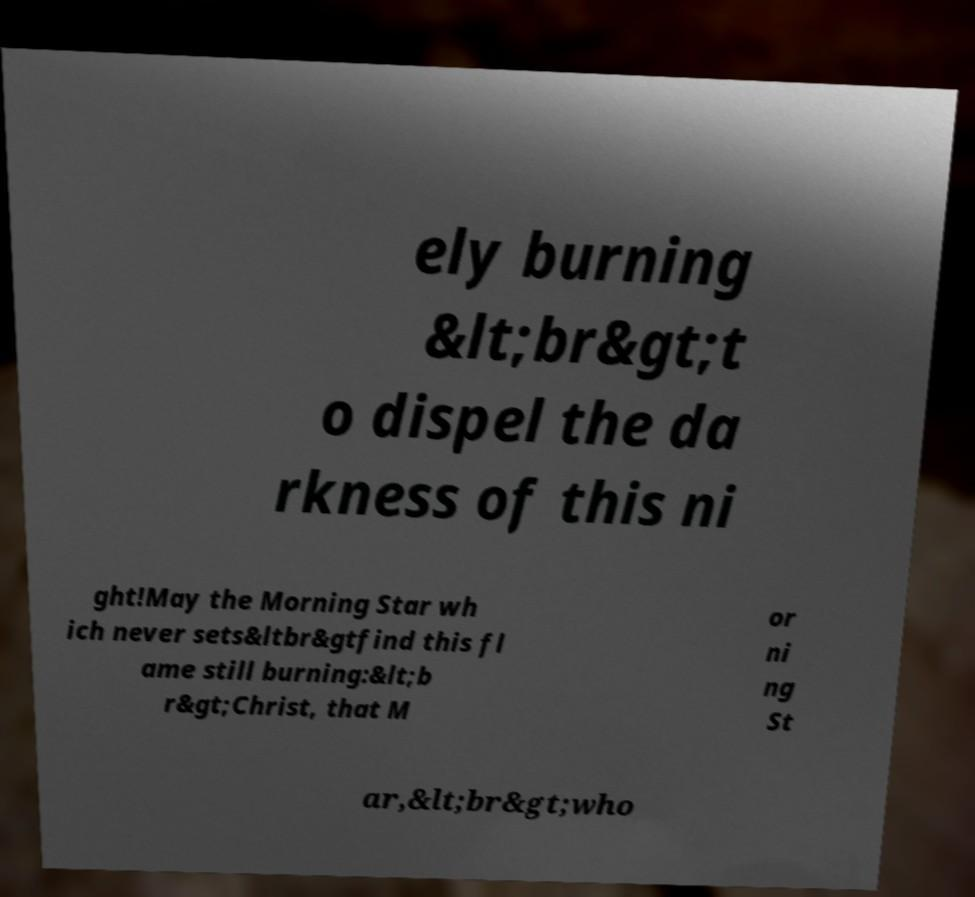I need the written content from this picture converted into text. Can you do that? ely burning &lt;br&gt;t o dispel the da rkness of this ni ght!May the Morning Star wh ich never sets&ltbr&gtfind this fl ame still burning:&lt;b r&gt;Christ, that M or ni ng St ar,&lt;br&gt;who 